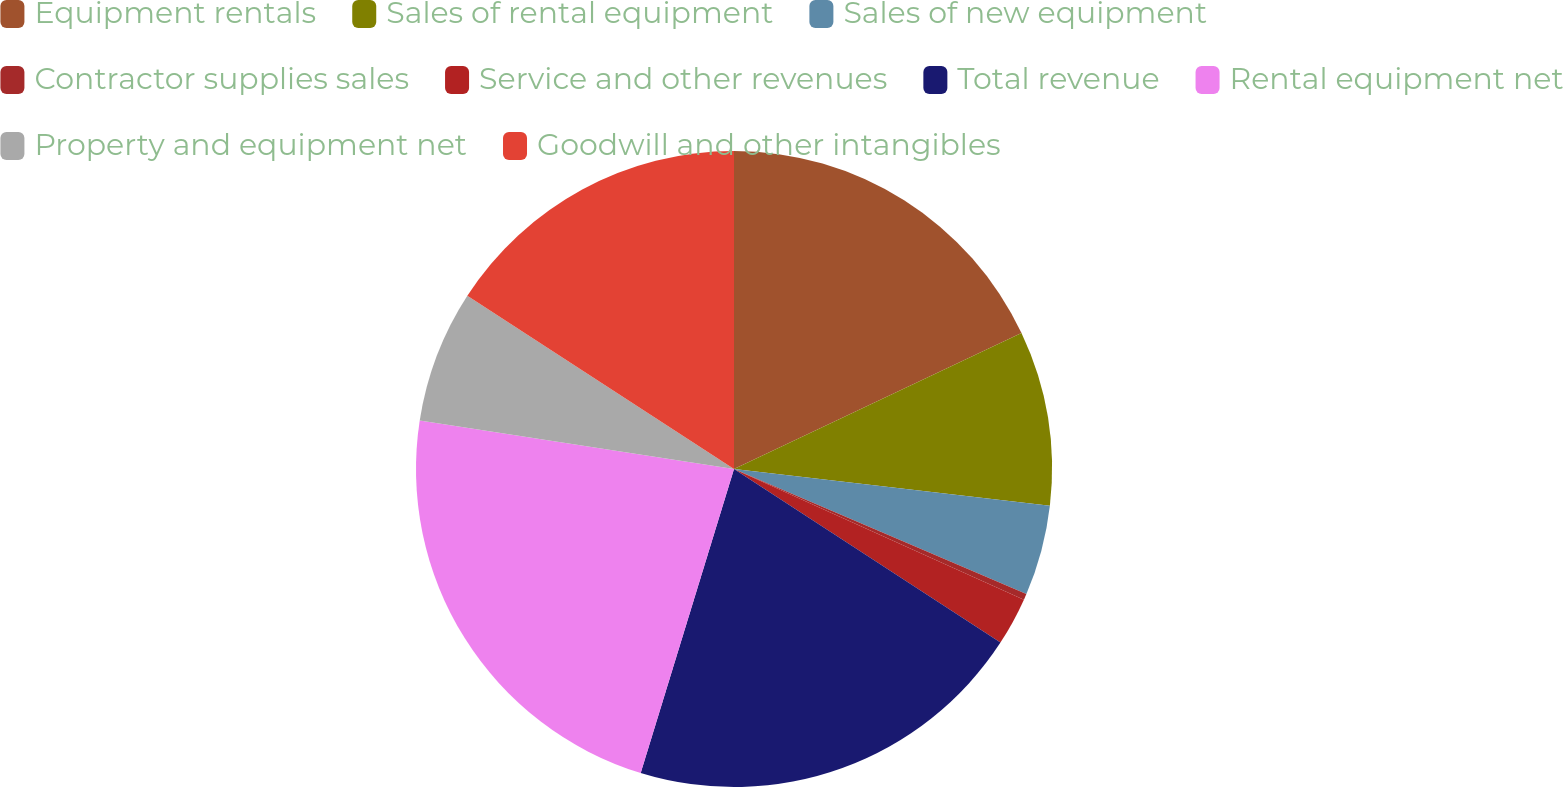Convert chart. <chart><loc_0><loc_0><loc_500><loc_500><pie_chart><fcel>Equipment rentals<fcel>Sales of rental equipment<fcel>Sales of new equipment<fcel>Contractor supplies sales<fcel>Service and other revenues<fcel>Total revenue<fcel>Rental equipment net<fcel>Property and equipment net<fcel>Goodwill and other intangibles<nl><fcel>17.97%<fcel>8.87%<fcel>4.59%<fcel>0.31%<fcel>2.45%<fcel>20.55%<fcel>22.7%<fcel>6.73%<fcel>15.83%<nl></chart> 